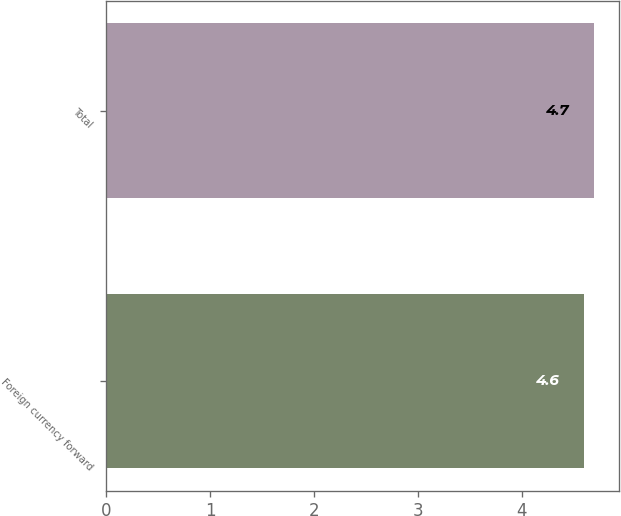Convert chart. <chart><loc_0><loc_0><loc_500><loc_500><bar_chart><fcel>Foreign currency forward<fcel>Total<nl><fcel>4.6<fcel>4.7<nl></chart> 